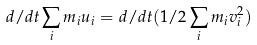Convert formula to latex. <formula><loc_0><loc_0><loc_500><loc_500>d / d t \sum _ { i } m _ { i } u _ { i } = d / d t ( 1 / 2 \sum _ { i } m _ { i } v _ { i } ^ { 2 } )</formula> 